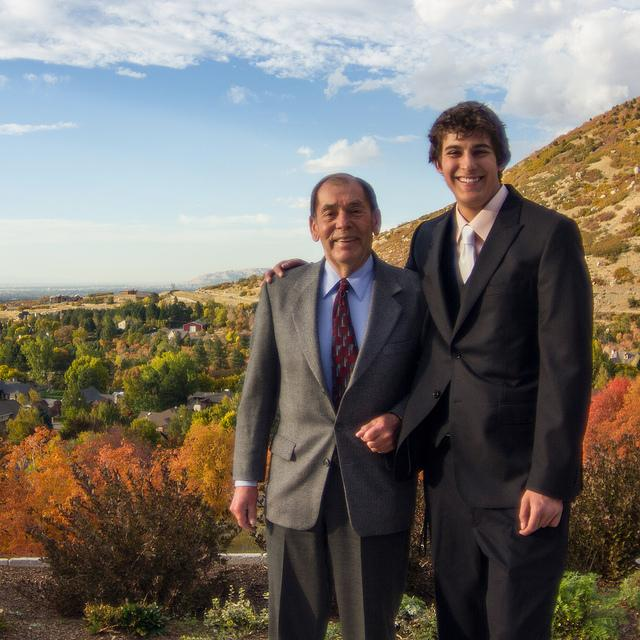What type setting do these men pose in? hillside 